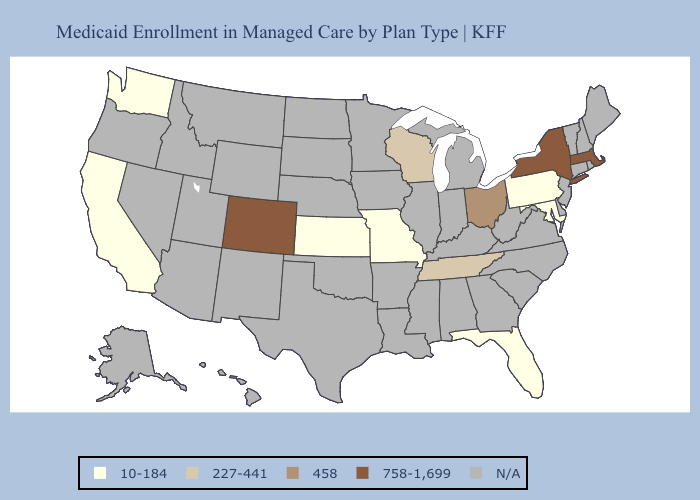Does Tennessee have the highest value in the USA?
Quick response, please. No. Which states hav the highest value in the Northeast?
Concise answer only. Massachusetts, New York. Does Missouri have the highest value in the MidWest?
Be succinct. No. Does the map have missing data?
Short answer required. Yes. Which states have the lowest value in the USA?
Be succinct. California, Florida, Kansas, Maryland, Missouri, Pennsylvania, Washington. Name the states that have a value in the range N/A?
Be succinct. Alabama, Alaska, Arizona, Arkansas, Connecticut, Delaware, Georgia, Hawaii, Idaho, Illinois, Indiana, Iowa, Kentucky, Louisiana, Maine, Michigan, Minnesota, Mississippi, Montana, Nebraska, Nevada, New Hampshire, New Jersey, New Mexico, North Carolina, North Dakota, Oklahoma, Oregon, Rhode Island, South Carolina, South Dakota, Texas, Utah, Vermont, Virginia, West Virginia, Wyoming. Is the legend a continuous bar?
Quick response, please. No. What is the value of Wisconsin?
Quick response, please. 227-441. Does the map have missing data?
Be succinct. Yes. Does Tennessee have the highest value in the South?
Be succinct. Yes. Does the map have missing data?
Write a very short answer. Yes. What is the value of Georgia?
Answer briefly. N/A. Name the states that have a value in the range 458?
Write a very short answer. Ohio. What is the lowest value in states that border North Carolina?
Concise answer only. 227-441. Which states have the lowest value in the West?
Write a very short answer. California, Washington. 